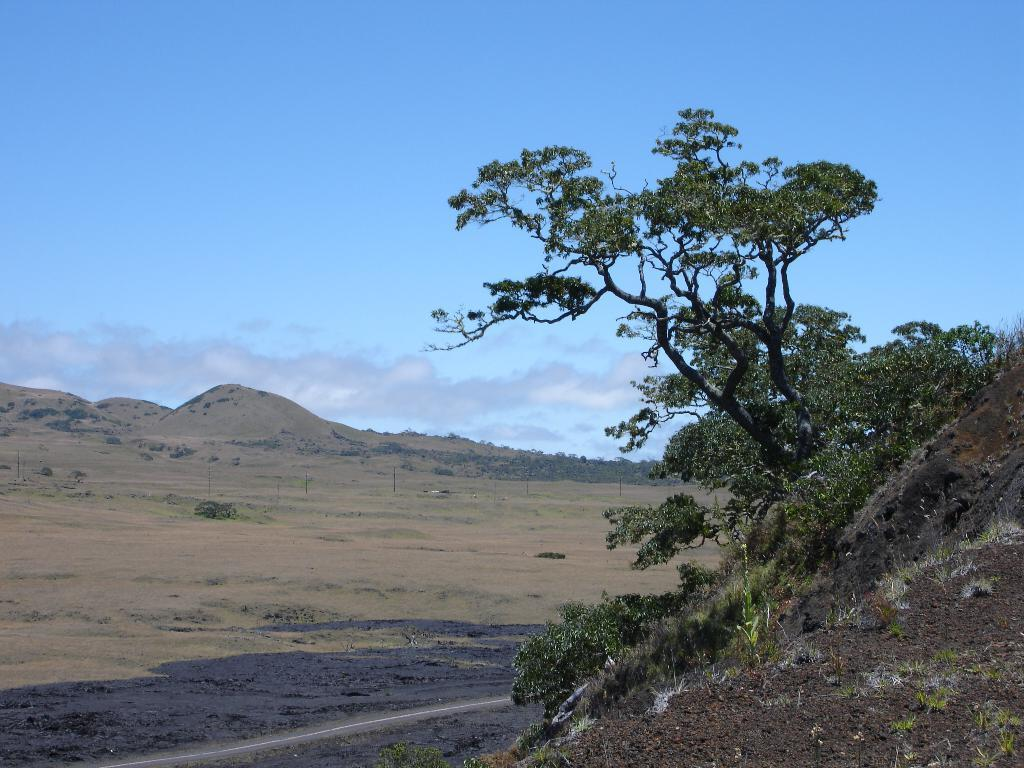What type of natural landform can be seen in the image? There are mountains in the image. What type of vegetation is present in the image? There are trees, plants, and grass in the image. What is visible in the sky in the image? The sky is visible in the image, and clouds are present. What type of quartz can be seen in the image? There is no quartz present in the image. Can you describe the bird that is flying in the image? There are no birds visible in the image. 